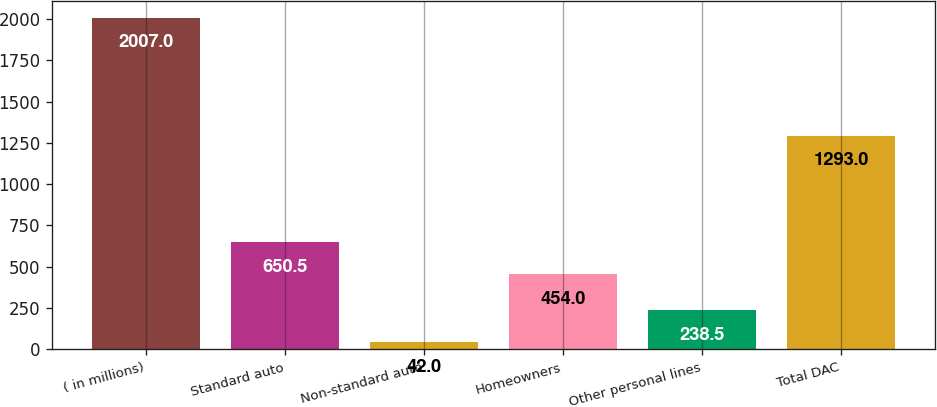Convert chart to OTSL. <chart><loc_0><loc_0><loc_500><loc_500><bar_chart><fcel>( in millions)<fcel>Standard auto<fcel>Non-standard auto<fcel>Homeowners<fcel>Other personal lines<fcel>Total DAC<nl><fcel>2007<fcel>650.5<fcel>42<fcel>454<fcel>238.5<fcel>1293<nl></chart> 